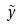Convert formula to latex. <formula><loc_0><loc_0><loc_500><loc_500>\tilde { y }</formula> 